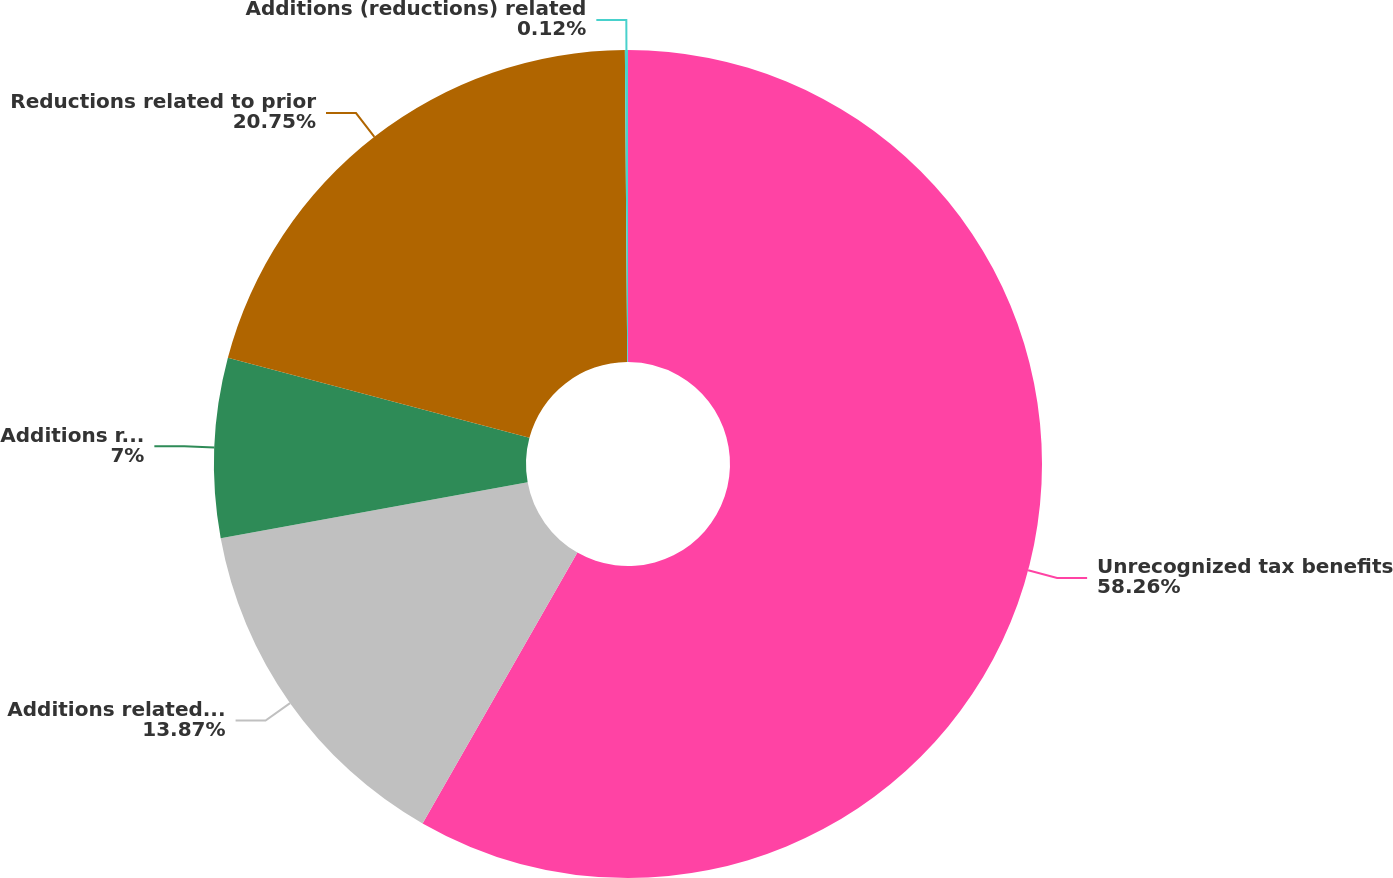<chart> <loc_0><loc_0><loc_500><loc_500><pie_chart><fcel>Unrecognized tax benefits<fcel>Additions related to current<fcel>Additions related to prior<fcel>Reductions related to prior<fcel>Additions (reductions) related<nl><fcel>58.27%<fcel>13.87%<fcel>7.0%<fcel>20.75%<fcel>0.12%<nl></chart> 